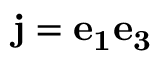<formula> <loc_0><loc_0><loc_500><loc_500>j = e _ { 1 } e _ { 3 }</formula> 